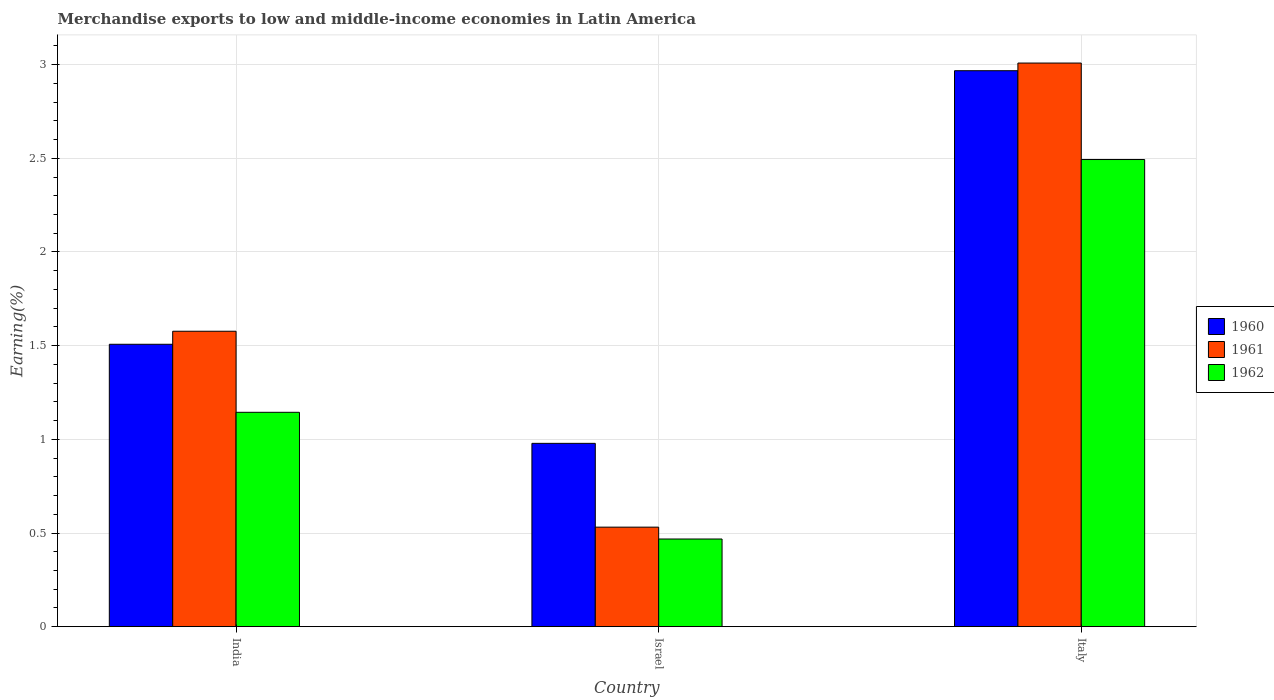How many different coloured bars are there?
Your answer should be compact. 3. How many groups of bars are there?
Ensure brevity in your answer.  3. Are the number of bars on each tick of the X-axis equal?
Provide a succinct answer. Yes. How many bars are there on the 3rd tick from the left?
Offer a terse response. 3. How many bars are there on the 3rd tick from the right?
Provide a short and direct response. 3. What is the percentage of amount earned from merchandise exports in 1960 in India?
Offer a very short reply. 1.51. Across all countries, what is the maximum percentage of amount earned from merchandise exports in 1961?
Give a very brief answer. 3.01. Across all countries, what is the minimum percentage of amount earned from merchandise exports in 1962?
Make the answer very short. 0.47. What is the total percentage of amount earned from merchandise exports in 1960 in the graph?
Your answer should be compact. 5.45. What is the difference between the percentage of amount earned from merchandise exports in 1961 in Israel and that in Italy?
Make the answer very short. -2.48. What is the difference between the percentage of amount earned from merchandise exports in 1961 in Israel and the percentage of amount earned from merchandise exports in 1960 in Italy?
Your answer should be compact. -2.44. What is the average percentage of amount earned from merchandise exports in 1961 per country?
Provide a succinct answer. 1.71. What is the difference between the percentage of amount earned from merchandise exports of/in 1960 and percentage of amount earned from merchandise exports of/in 1962 in India?
Provide a short and direct response. 0.36. In how many countries, is the percentage of amount earned from merchandise exports in 1961 greater than 0.9 %?
Ensure brevity in your answer.  2. What is the ratio of the percentage of amount earned from merchandise exports in 1961 in India to that in Israel?
Provide a succinct answer. 2.97. What is the difference between the highest and the second highest percentage of amount earned from merchandise exports in 1962?
Your response must be concise. -0.68. What is the difference between the highest and the lowest percentage of amount earned from merchandise exports in 1960?
Offer a very short reply. 1.99. Is the sum of the percentage of amount earned from merchandise exports in 1960 in Israel and Italy greater than the maximum percentage of amount earned from merchandise exports in 1961 across all countries?
Provide a short and direct response. Yes. What does the 1st bar from the right in Italy represents?
Your response must be concise. 1962. How many bars are there?
Keep it short and to the point. 9. Are all the bars in the graph horizontal?
Give a very brief answer. No. Does the graph contain grids?
Make the answer very short. Yes. How many legend labels are there?
Provide a short and direct response. 3. What is the title of the graph?
Make the answer very short. Merchandise exports to low and middle-income economies in Latin America. Does "1982" appear as one of the legend labels in the graph?
Offer a terse response. No. What is the label or title of the X-axis?
Offer a terse response. Country. What is the label or title of the Y-axis?
Offer a very short reply. Earning(%). What is the Earning(%) of 1960 in India?
Your answer should be compact. 1.51. What is the Earning(%) in 1961 in India?
Offer a terse response. 1.58. What is the Earning(%) of 1962 in India?
Keep it short and to the point. 1.14. What is the Earning(%) in 1960 in Israel?
Offer a terse response. 0.98. What is the Earning(%) of 1961 in Israel?
Your answer should be compact. 0.53. What is the Earning(%) of 1962 in Israel?
Keep it short and to the point. 0.47. What is the Earning(%) of 1960 in Italy?
Your answer should be very brief. 2.97. What is the Earning(%) of 1961 in Italy?
Your answer should be compact. 3.01. What is the Earning(%) of 1962 in Italy?
Your answer should be compact. 2.49. Across all countries, what is the maximum Earning(%) of 1960?
Offer a terse response. 2.97. Across all countries, what is the maximum Earning(%) of 1961?
Your response must be concise. 3.01. Across all countries, what is the maximum Earning(%) in 1962?
Provide a short and direct response. 2.49. Across all countries, what is the minimum Earning(%) in 1960?
Give a very brief answer. 0.98. Across all countries, what is the minimum Earning(%) in 1961?
Offer a terse response. 0.53. Across all countries, what is the minimum Earning(%) of 1962?
Your response must be concise. 0.47. What is the total Earning(%) of 1960 in the graph?
Provide a succinct answer. 5.45. What is the total Earning(%) in 1961 in the graph?
Offer a very short reply. 5.12. What is the total Earning(%) of 1962 in the graph?
Offer a terse response. 4.11. What is the difference between the Earning(%) of 1960 in India and that in Israel?
Make the answer very short. 0.53. What is the difference between the Earning(%) in 1961 in India and that in Israel?
Your response must be concise. 1.05. What is the difference between the Earning(%) of 1962 in India and that in Israel?
Give a very brief answer. 0.68. What is the difference between the Earning(%) in 1960 in India and that in Italy?
Give a very brief answer. -1.46. What is the difference between the Earning(%) of 1961 in India and that in Italy?
Offer a very short reply. -1.43. What is the difference between the Earning(%) in 1962 in India and that in Italy?
Provide a succinct answer. -1.35. What is the difference between the Earning(%) in 1960 in Israel and that in Italy?
Make the answer very short. -1.99. What is the difference between the Earning(%) of 1961 in Israel and that in Italy?
Your answer should be compact. -2.48. What is the difference between the Earning(%) of 1962 in Israel and that in Italy?
Your answer should be compact. -2.03. What is the difference between the Earning(%) of 1960 in India and the Earning(%) of 1961 in Israel?
Offer a very short reply. 0.98. What is the difference between the Earning(%) in 1960 in India and the Earning(%) in 1962 in Israel?
Offer a very short reply. 1.04. What is the difference between the Earning(%) of 1961 in India and the Earning(%) of 1962 in Israel?
Your answer should be compact. 1.11. What is the difference between the Earning(%) in 1960 in India and the Earning(%) in 1961 in Italy?
Your answer should be very brief. -1.5. What is the difference between the Earning(%) of 1960 in India and the Earning(%) of 1962 in Italy?
Offer a very short reply. -0.99. What is the difference between the Earning(%) in 1961 in India and the Earning(%) in 1962 in Italy?
Make the answer very short. -0.92. What is the difference between the Earning(%) in 1960 in Israel and the Earning(%) in 1961 in Italy?
Your answer should be compact. -2.03. What is the difference between the Earning(%) of 1960 in Israel and the Earning(%) of 1962 in Italy?
Offer a very short reply. -1.51. What is the difference between the Earning(%) in 1961 in Israel and the Earning(%) in 1962 in Italy?
Your response must be concise. -1.96. What is the average Earning(%) of 1960 per country?
Your answer should be compact. 1.82. What is the average Earning(%) of 1961 per country?
Provide a short and direct response. 1.71. What is the average Earning(%) in 1962 per country?
Keep it short and to the point. 1.37. What is the difference between the Earning(%) of 1960 and Earning(%) of 1961 in India?
Provide a succinct answer. -0.07. What is the difference between the Earning(%) of 1960 and Earning(%) of 1962 in India?
Keep it short and to the point. 0.36. What is the difference between the Earning(%) of 1961 and Earning(%) of 1962 in India?
Provide a short and direct response. 0.43. What is the difference between the Earning(%) in 1960 and Earning(%) in 1961 in Israel?
Provide a short and direct response. 0.45. What is the difference between the Earning(%) of 1960 and Earning(%) of 1962 in Israel?
Ensure brevity in your answer.  0.51. What is the difference between the Earning(%) in 1961 and Earning(%) in 1962 in Israel?
Your answer should be compact. 0.06. What is the difference between the Earning(%) of 1960 and Earning(%) of 1961 in Italy?
Your answer should be compact. -0.04. What is the difference between the Earning(%) of 1960 and Earning(%) of 1962 in Italy?
Make the answer very short. 0.47. What is the difference between the Earning(%) of 1961 and Earning(%) of 1962 in Italy?
Provide a short and direct response. 0.51. What is the ratio of the Earning(%) in 1960 in India to that in Israel?
Provide a succinct answer. 1.54. What is the ratio of the Earning(%) of 1961 in India to that in Israel?
Provide a succinct answer. 2.97. What is the ratio of the Earning(%) in 1962 in India to that in Israel?
Keep it short and to the point. 2.45. What is the ratio of the Earning(%) in 1960 in India to that in Italy?
Your response must be concise. 0.51. What is the ratio of the Earning(%) of 1961 in India to that in Italy?
Provide a succinct answer. 0.52. What is the ratio of the Earning(%) of 1962 in India to that in Italy?
Your response must be concise. 0.46. What is the ratio of the Earning(%) in 1960 in Israel to that in Italy?
Make the answer very short. 0.33. What is the ratio of the Earning(%) of 1961 in Israel to that in Italy?
Make the answer very short. 0.18. What is the ratio of the Earning(%) of 1962 in Israel to that in Italy?
Provide a short and direct response. 0.19. What is the difference between the highest and the second highest Earning(%) of 1960?
Give a very brief answer. 1.46. What is the difference between the highest and the second highest Earning(%) of 1961?
Give a very brief answer. 1.43. What is the difference between the highest and the second highest Earning(%) of 1962?
Your answer should be very brief. 1.35. What is the difference between the highest and the lowest Earning(%) in 1960?
Your answer should be compact. 1.99. What is the difference between the highest and the lowest Earning(%) in 1961?
Make the answer very short. 2.48. What is the difference between the highest and the lowest Earning(%) of 1962?
Offer a terse response. 2.03. 